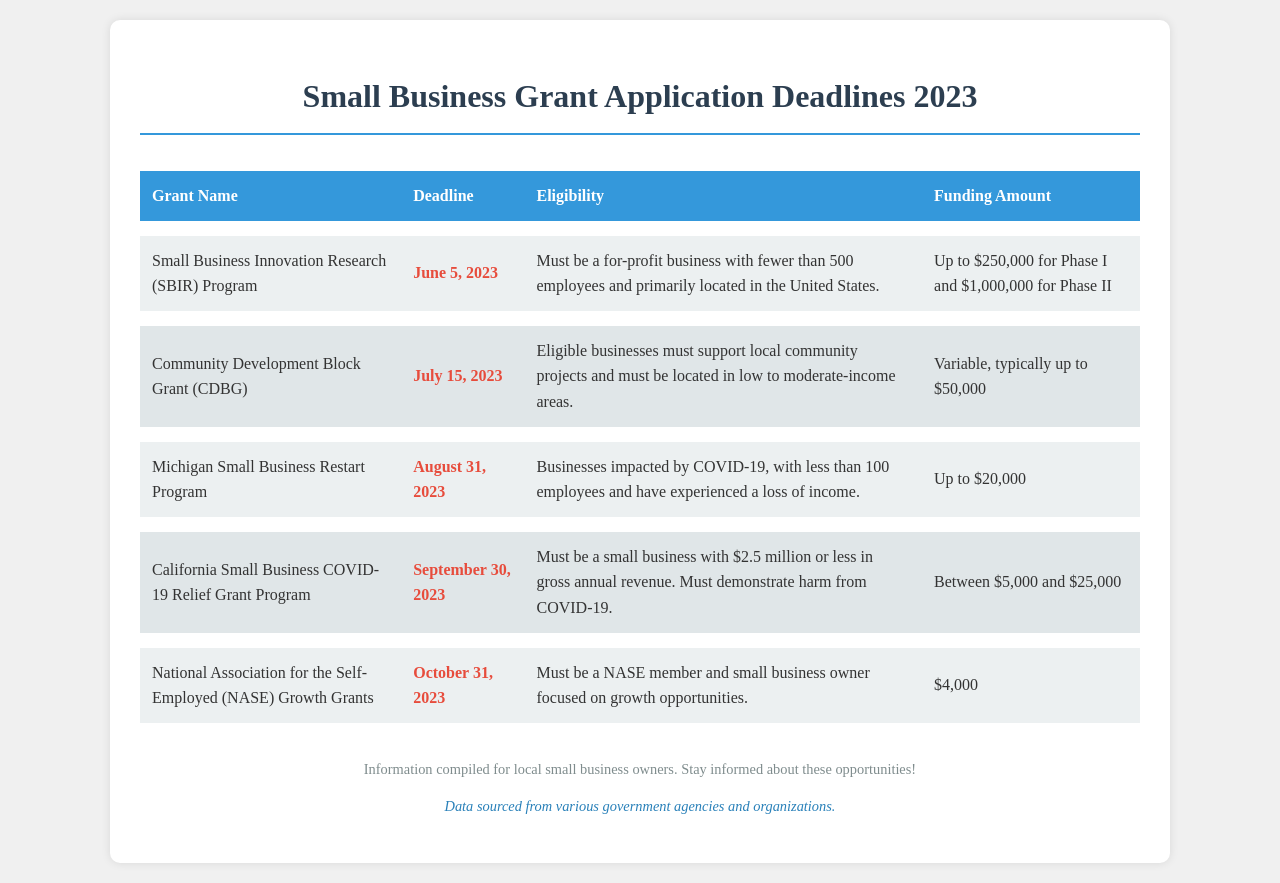What is the deadline for the SBIR Program? The deadline for the SBIR Program is June 5, 2023, as stated in the document.
Answer: June 5, 2023 What is the funding amount for the CDBG? The document specifies that the funding amount for the CDBG is variable, typically providing up to $50,000.
Answer: Up to $50,000 What eligibility requirement is stated for the Michigan Small Business Restart Program? The document states that eligible businesses must have been impacted by COVID-19 and have experienced a loss of income.
Answer: Impacted by COVID-19, loss of income How much can a California small business receive from the COVID-19 Relief Grant Program? According to the document, the funding amount ranges between $5,000 and $25,000 for the California Small Business COVID-19 Relief Grant Program.
Answer: Between $5,000 and $25,000 Which grant has the latest application deadline in 2023? The document shows that the National Association for the Self-Employed Growth Grants have the latest deadline of October 31, 2023.
Answer: October 31, 2023 What type of businesses must apply for the SBIR Program? The document specifies that applicants must be for-profit businesses with fewer than 500 employees.
Answer: For-profit businesses Which grant requires NASE membership? The document indicates that the NASE Growth Grants require that the applicant is a NASE member.
Answer: NASE Growth Grants What is the primary purpose of the CDBG grant? The document states that the CDBG grant's purpose is to support local community projects.
Answer: Support local community projects 